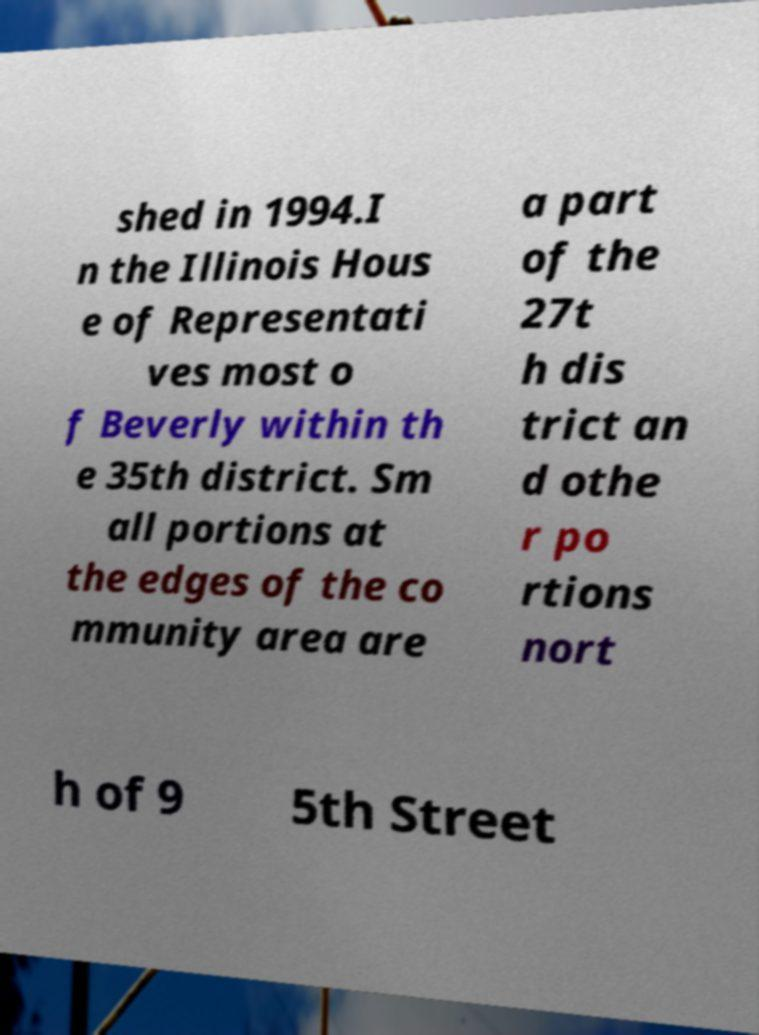Can you accurately transcribe the text from the provided image for me? shed in 1994.I n the Illinois Hous e of Representati ves most o f Beverly within th e 35th district. Sm all portions at the edges of the co mmunity area are a part of the 27t h dis trict an d othe r po rtions nort h of 9 5th Street 